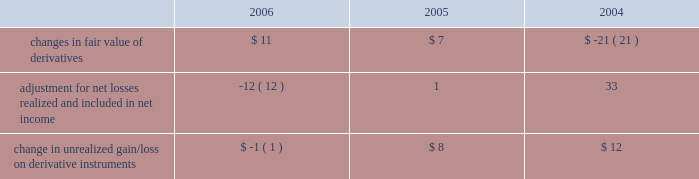Notes to consolidated financial statements ( continued ) note 8 2014shareholders 2019 equity ( continued ) the table summarizes activity in other comprehensive income related to derivatives , net of taxes , held by the company ( in millions ) : .
The tax effect related to the changes in fair value of derivatives was $ ( 8 ) million , $ ( 3 ) million , and $ 10 million for 2006 , 2005 , and 2004 , respectively .
The tax effect related to derivative gains/losses reclassified from other comprehensive income to net income was $ 8 million , $ ( 2 ) million , and $ ( 13 ) million for 2006 , 2005 , and 2004 , respectively .
Employee benefit plans 2003 employee stock plan the 2003 employee stock plan ( the 201c2003 plan 201d ) is a shareholder approved plan that provides for broad- based grants to employees , including executive officers .
Based on the terms of individual option grants , options granted under the 2003 plan generally expire 7 to 10 years after the grant date and generally become exercisable over a period of 4 years , based on continued employment , with either annual or quarterly vesting .
The 2003 plan permits the granting of incentive stock options , nonstatutory stock options , restricted stock units , stock appreciation rights , and stock purchase rights .
1997 employee stock option plan in august 1997 , the company 2019s board of directors approved the 1997 employee stock option plan ( the 201c1997 plan 201d ) , a non-shareholder approved plan for grants of stock options to employees who are not officers of the company .
Based on the terms of individual option grants , options granted under the 1997 plan generally expire 7 to 10 years after the grant date and generally become exercisable over a period of 4 years , based on continued employment , with either annual or quarterly vesting .
In october 2003 , the company terminated the 1997 employee stock option plan and cancelled all remaining unissued shares totaling 28590702 .
No new options can be granted from the 1997 plan .
Employee stock option exchange program on march 20 , 2003 , the company announced a voluntary employee stock option exchange program ( the 201cexchange program 201d ) whereby eligible employees , other than executive officers and members of the board of directors , had an opportunity to exchange outstanding options with exercise prices at or above $ 12.50 per share for a predetermined smaller number of new stock options issued with exercise prices equal to the fair market value of one share of the company 2019s common stock on the day the new awards were issued , which was to be at least six months plus one day after the exchange options were cancelled .
On april 17 , 2003 , in accordance with the exchange program , the company cancelled options to purchase 33138386 shares of its common stock .
On october 22 , 2003 , new stock options totaling 13394736 shares were issued to employees at an exercise price of $ 11.38 per share , which is equivalent to the closing price of the company 2019s stock on that date .
No financial or accounting impact to the company 2019s financial position , results of operations or cash flows was associated with this transaction. .
What was the total dollar amount of new stock options issues to employees on october 22 , 2003? 
Computations: (13394736 * 11.38)
Answer: 152432095.68. 